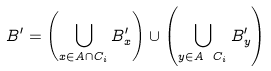<formula> <loc_0><loc_0><loc_500><loc_500>B ^ { \prime } = \left ( \bigcup _ { x \in A \cap C _ { i } } B ^ { \prime } _ { x } \right ) \cup \left ( \bigcup _ { y \in A \ C _ { i } } B ^ { \prime } _ { y } \right )</formula> 